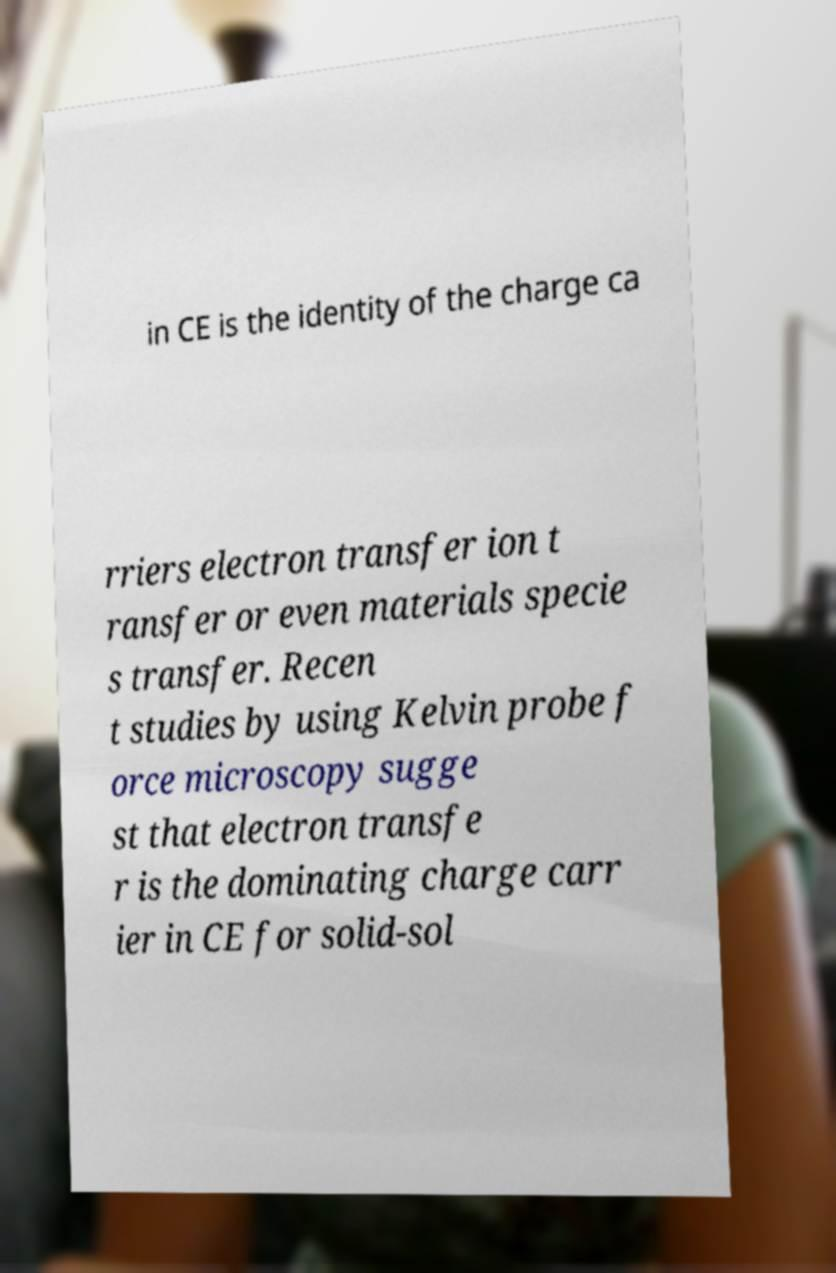Please read and relay the text visible in this image. What does it say? in CE is the identity of the charge ca rriers electron transfer ion t ransfer or even materials specie s transfer. Recen t studies by using Kelvin probe f orce microscopy sugge st that electron transfe r is the dominating charge carr ier in CE for solid-sol 